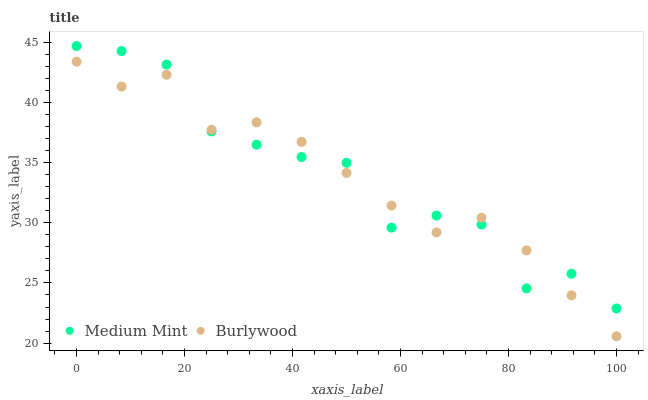Does Burlywood have the minimum area under the curve?
Answer yes or no. Yes. Does Medium Mint have the maximum area under the curve?
Answer yes or no. Yes. Does Burlywood have the maximum area under the curve?
Answer yes or no. No. Is Burlywood the smoothest?
Answer yes or no. Yes. Is Medium Mint the roughest?
Answer yes or no. Yes. Is Burlywood the roughest?
Answer yes or no. No. Does Burlywood have the lowest value?
Answer yes or no. Yes. Does Medium Mint have the highest value?
Answer yes or no. Yes. Does Burlywood have the highest value?
Answer yes or no. No. Does Burlywood intersect Medium Mint?
Answer yes or no. Yes. Is Burlywood less than Medium Mint?
Answer yes or no. No. Is Burlywood greater than Medium Mint?
Answer yes or no. No. 